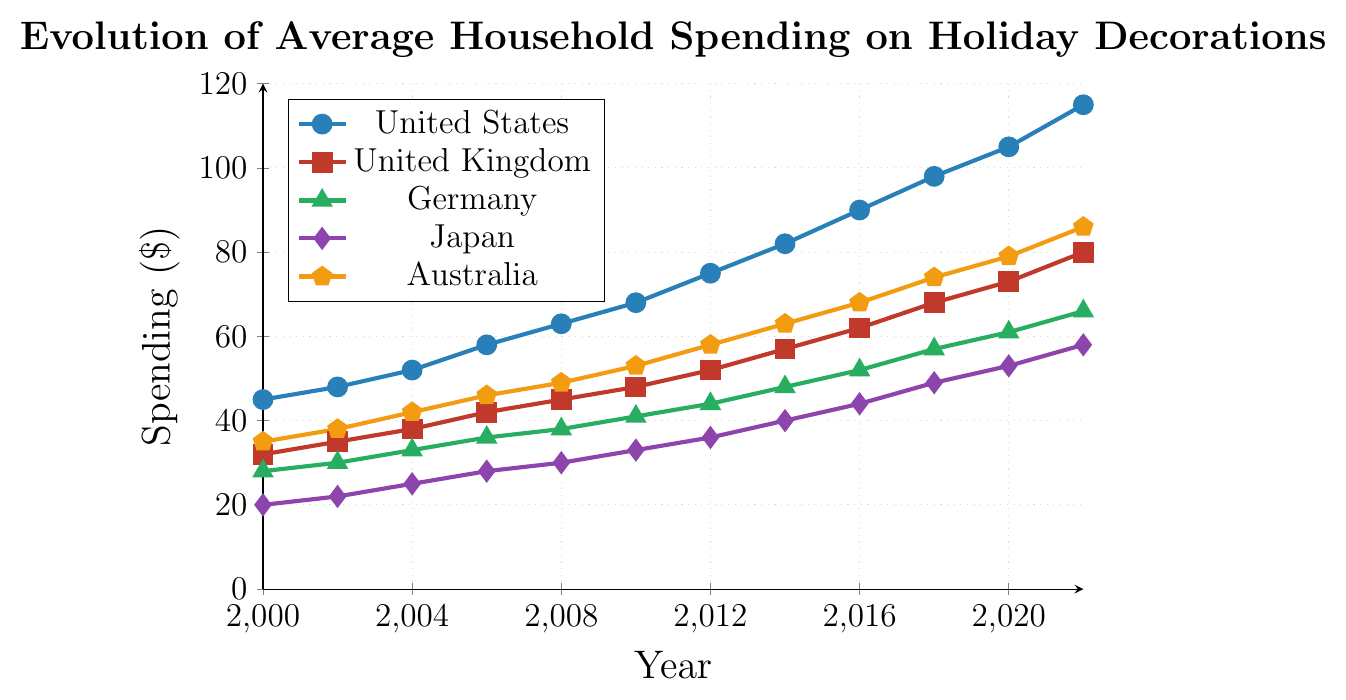What's the spending of the United States in 2010? Locate the line corresponding to the United States and find the value at the x-coordinate for the year 2010.
Answer: 68 Which country had the highest spending on holiday decorations in 2022? Compare the values for all countries at the year 2022. The highest value is for the United States.
Answer: United States How much more did households in Australia spend in 2008 compared to Japan in the same year? Find the values for both Australia and Japan in 2008 and calculate the difference: 49 - 30 = 19.
Answer: 19 Between which two consecutive years did Germany see the largest increase in spending? Calculate the difference in spending for consecutive years for Germany and identify the largest difference. From 2010 to 2012, the increase is 44 - 41 = 3, which is the largest.
Answer: 2010-2012 What was the overall trend in spending for the United Kingdom from 2000 to 2022? Visually check the general direction of the line for the United Kingdom from 2000 to 2022, which shows a consistently increasing trend.
Answer: Increasing How does the spending on holiday decorations in Japan in 2014 compare to Germany in the same year? Compare the values for Japan and Germany in 2014: Japan = 40, Germany = 48. Japan's spending is less than Germany's.
Answer: Less In which year did households in the United States first exceed $100 in spending? Trace the United States line to identify the year when the value first exceeded 100, which is in 2020.
Answer: 2020 Calculate the average spending in 2022 for all five countries. Sum the values for all countries in 2022 and divide by the number of countries: (115 + 80 + 66 + 58 + 86) / 5 = 81
Answer: 81 Which country had the smallest increase in spending from 2000 to 2022? Calculate the difference in spending from 2000 to 2022 for each country and find the smallest difference: Germany's increase is 66 - 28 = 38, which is the smallest.
Answer: Germany What color represents Japan in the plot? Look at the legend on the right and identify the color corresponding to Japan.
Answer: Purple 